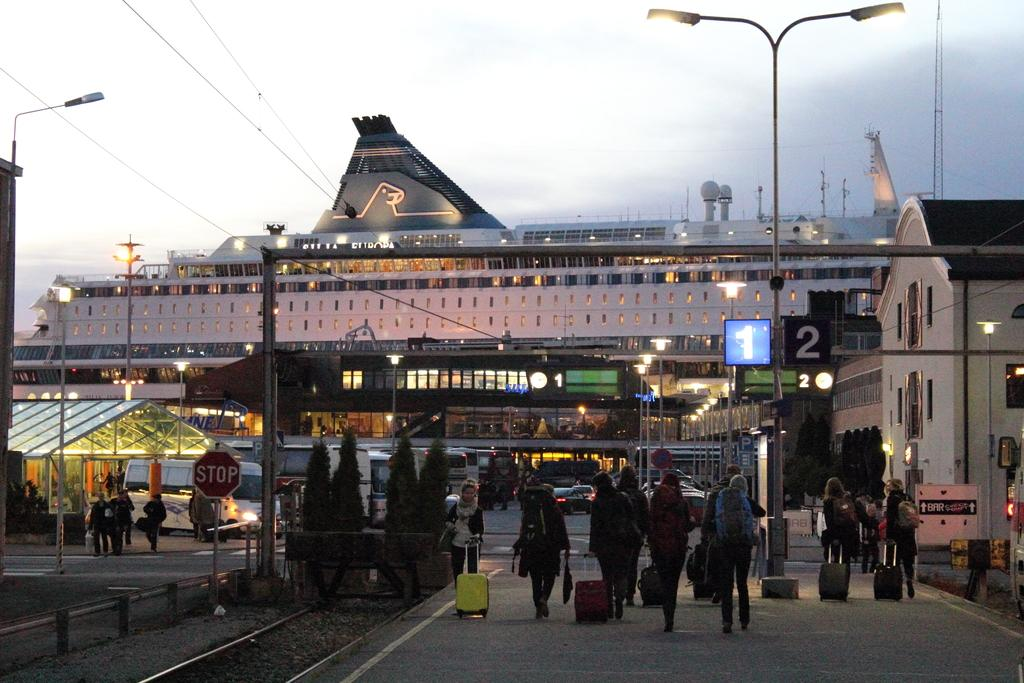What are the people in the image doing? The people in the image are walking on the road. What are the people carrying while walking? The people are carrying bags. What structures can be seen in the background of the image? There are buildings in the image. What else can be seen in the image besides people and buildings? There are poles visible in the image. What type of cent can be seen spinning on the poles in the image? There is no cent present in the image; it features people walking on the road and carrying bags, with buildings and poles in the background. 